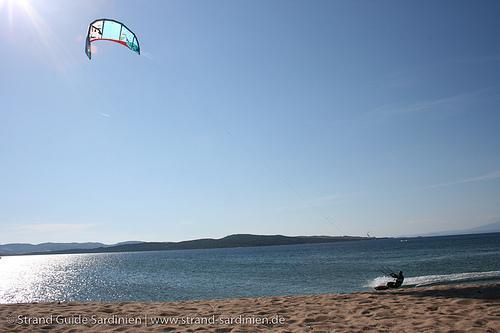How many people are there?
Give a very brief answer. 1. 